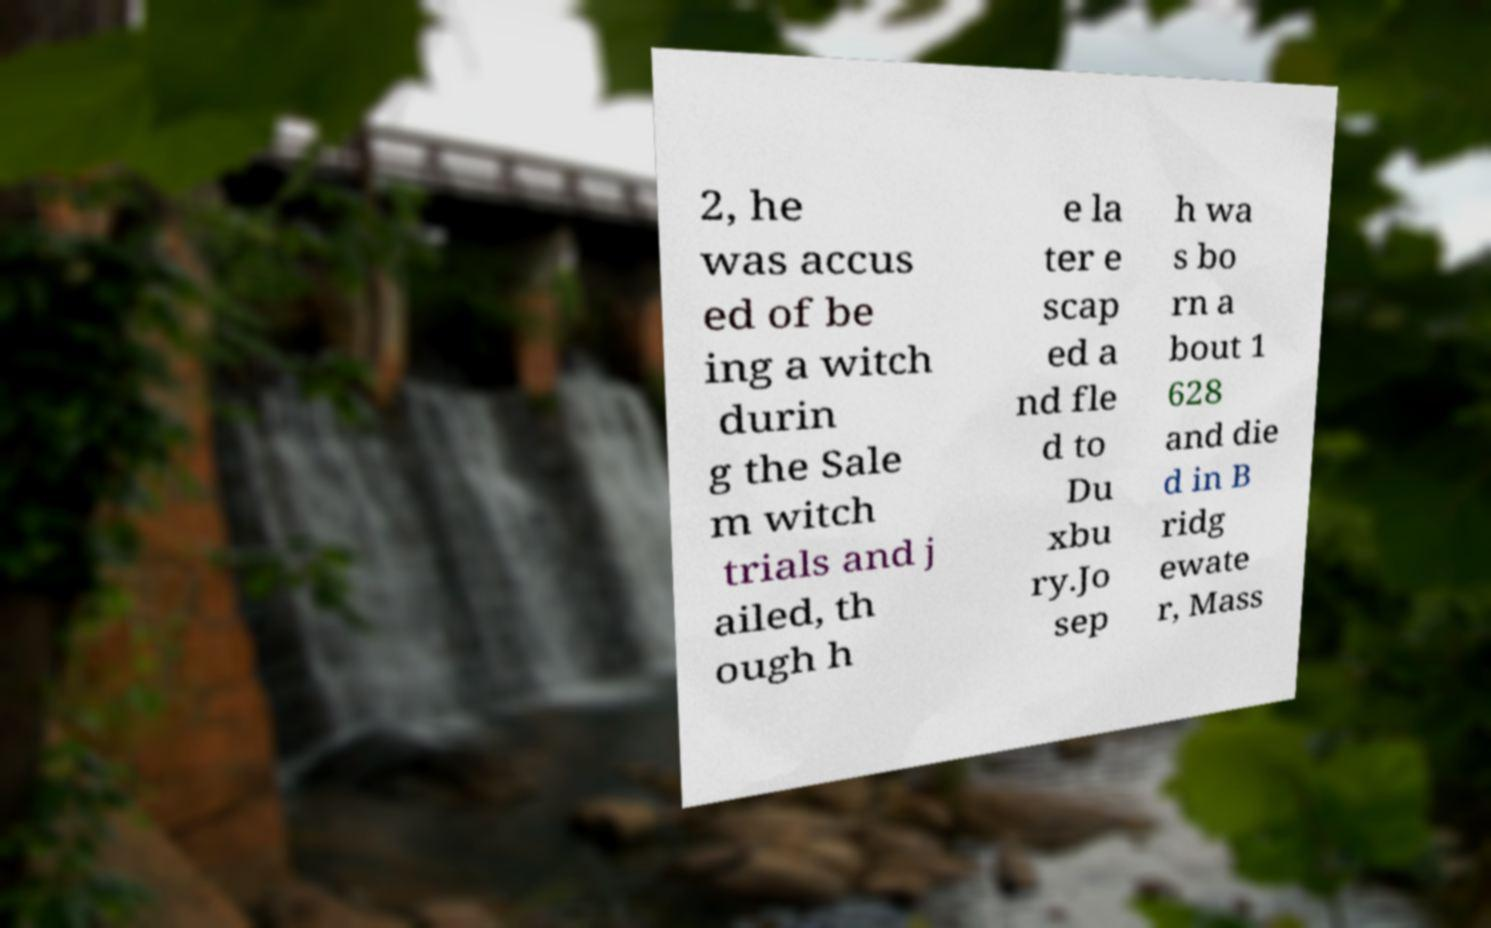Please read and relay the text visible in this image. What does it say? 2, he was accus ed of be ing a witch durin g the Sale m witch trials and j ailed, th ough h e la ter e scap ed a nd fle d to Du xbu ry.Jo sep h wa s bo rn a bout 1 628 and die d in B ridg ewate r, Mass 